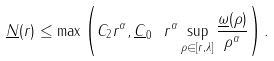Convert formula to latex. <formula><loc_0><loc_0><loc_500><loc_500>\underline { N } ( r ) \leq \max \left ( C _ { 2 } r ^ { \alpha } , \underline { C } _ { 0 } \ r ^ { \alpha } \sup _ { \rho \in [ r , \lambda ] } \frac { \underline { \omega } ( \rho ) } { \rho ^ { \alpha } } \right ) .</formula> 